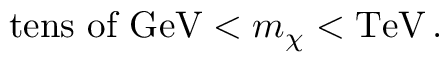<formula> <loc_0><loc_0><loc_500><loc_500>t e n s o f G e V < m _ { \chi } < T e V \, .</formula> 